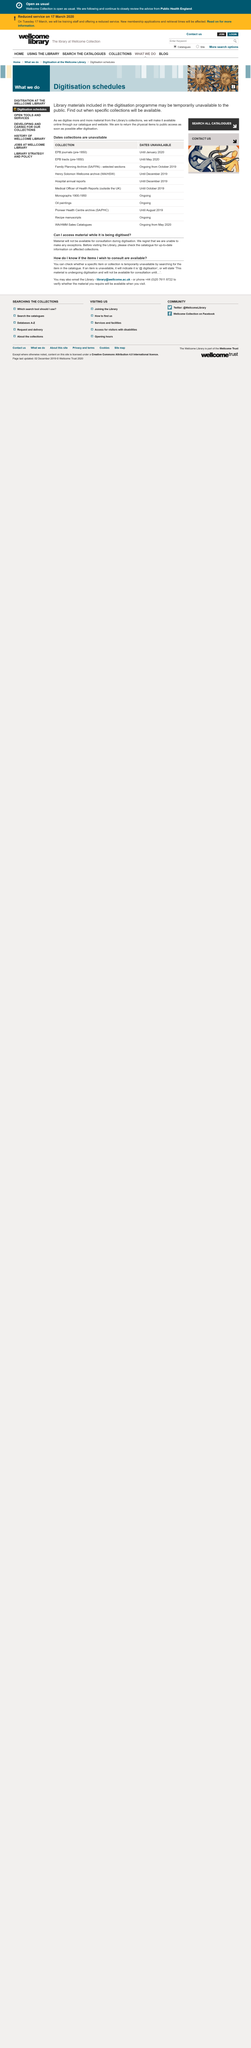List a handful of essential elements in this visual. Material may not be accessed while it is being digitised, as it is being processed and cannot be accessed simultaneously. It is possible to verify the catalogue for current details by searching for specific items or collections. When an item has a digitization message, it is considered unavailable. 